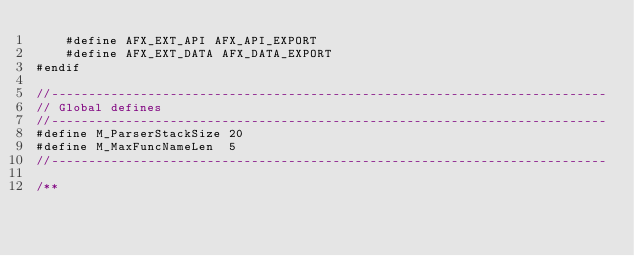<code> <loc_0><loc_0><loc_500><loc_500><_C_>    #define AFX_EXT_API AFX_API_EXPORT
    #define AFX_EXT_DATA AFX_DATA_EXPORT
#endif

//---------------------------------------------------------------------------
// Global defines
//---------------------------------------------------------------------------
#define M_ParserStackSize 20
#define M_MaxFuncNameLen  5
//---------------------------------------------------------------------------

/**</code> 